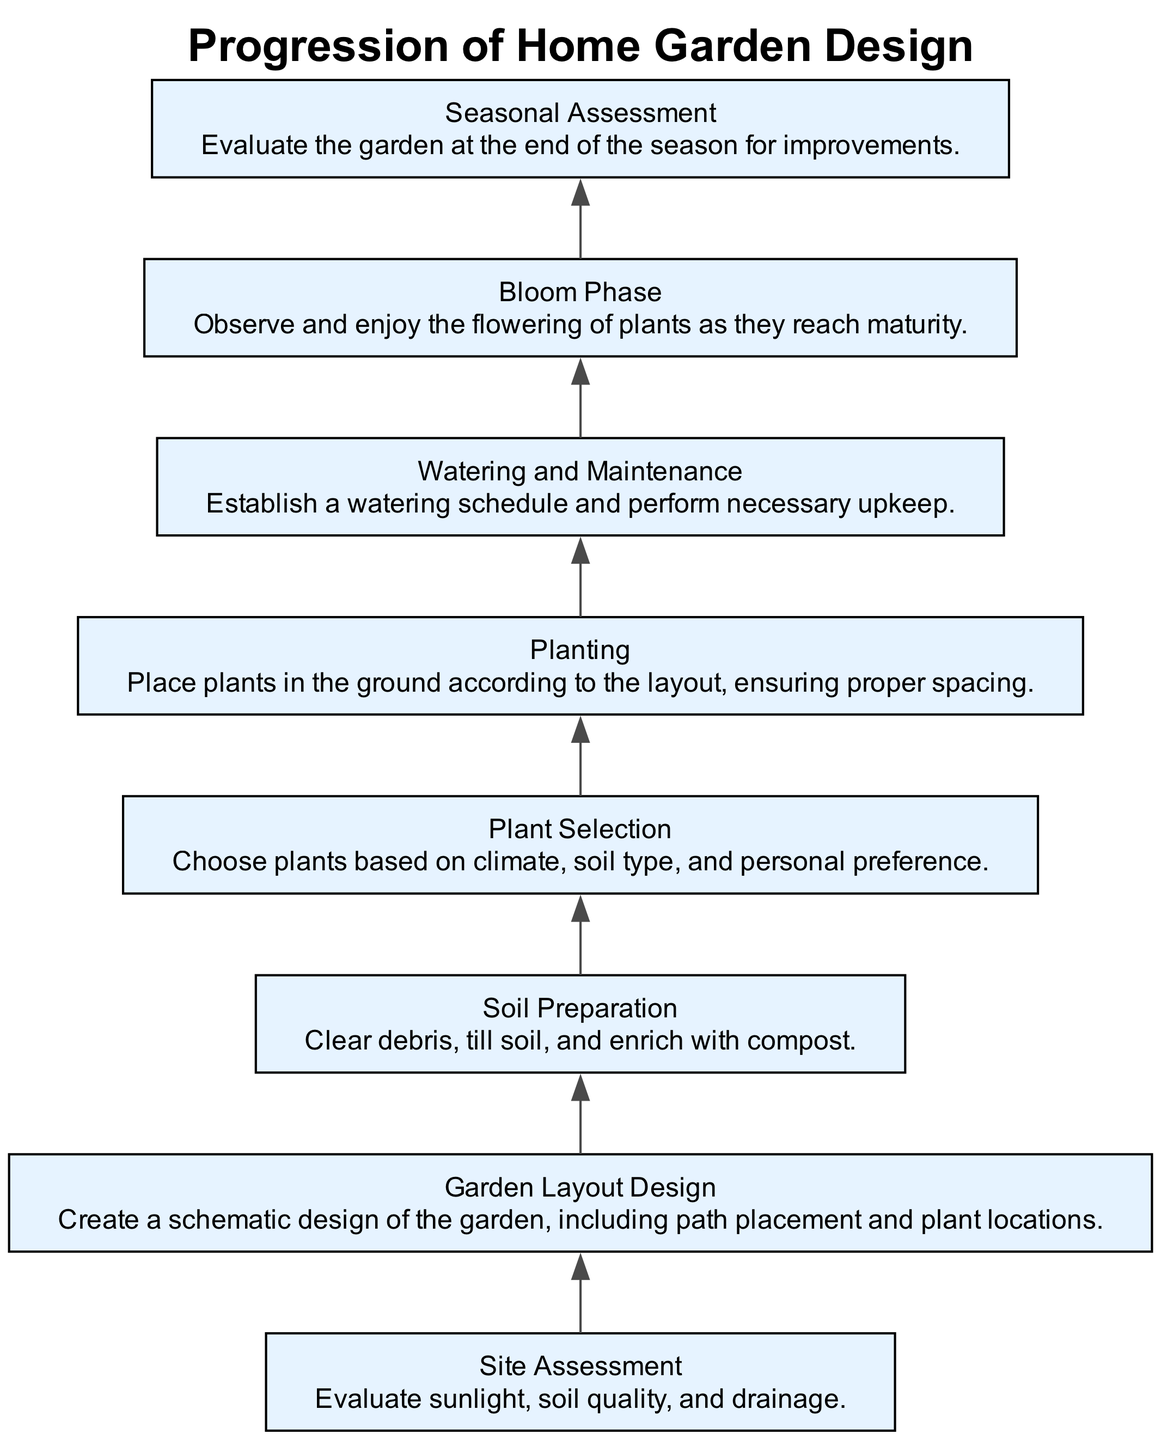What is the first step in the garden design process? The first step in the diagram is "Site Assessment," which focuses on evaluating sunlight, soil quality, and drainage.
Answer: Site Assessment How many main phases are presented in the diagram? The diagram presents 8 main phases from initial layout to final blooming, which can be counted visually.
Answer: 8 What follows after "Soil Preparation"? After "Soil Preparation," the next phase is "Plant Selection," indicating the order of operations in garden design.
Answer: Plant Selection Which phase involves evaluating the garden at the end of the season? The phase that involves evaluating the garden at the end of the season is "Seasonal Assessment," which focuses on improvements for future growth.
Answer: Seasonal Assessment In the progression flow, which action comes before "Watering and Maintenance"? "Planting" comes before "Watering and Maintenance"; the diagram clearly shows this sequential relationship.
Answer: Planting What type of information is assessed in the "Site Assessment"? "Site Assessment" assesses several environmental factors, including sunlight, soil quality, and drainage prior to starting the garden design.
Answer: Sunlight, soil quality, and drainage Identify two elements that are directly linked in the diagram. "Plant Selection" and "Planting" are directly linked; after selecting plants, they must be planted according to the layout.
Answer: Plant Selection, Planting Which nodes are at the top and bottom of the flow chart, respectively? The top node is "Site Assessment," and the bottom node is "Bloom Phase," representing the start and completion of the garden design process.
Answer: Site Assessment, Bloom Phase What is the main purpose of the "Bloom Phase"? The main purpose of the "Bloom Phase" is to observe and enjoy the flowering of plants as they reach maturity, marking the successful completion of the garden design.
Answer: Observe and enjoy flowering 